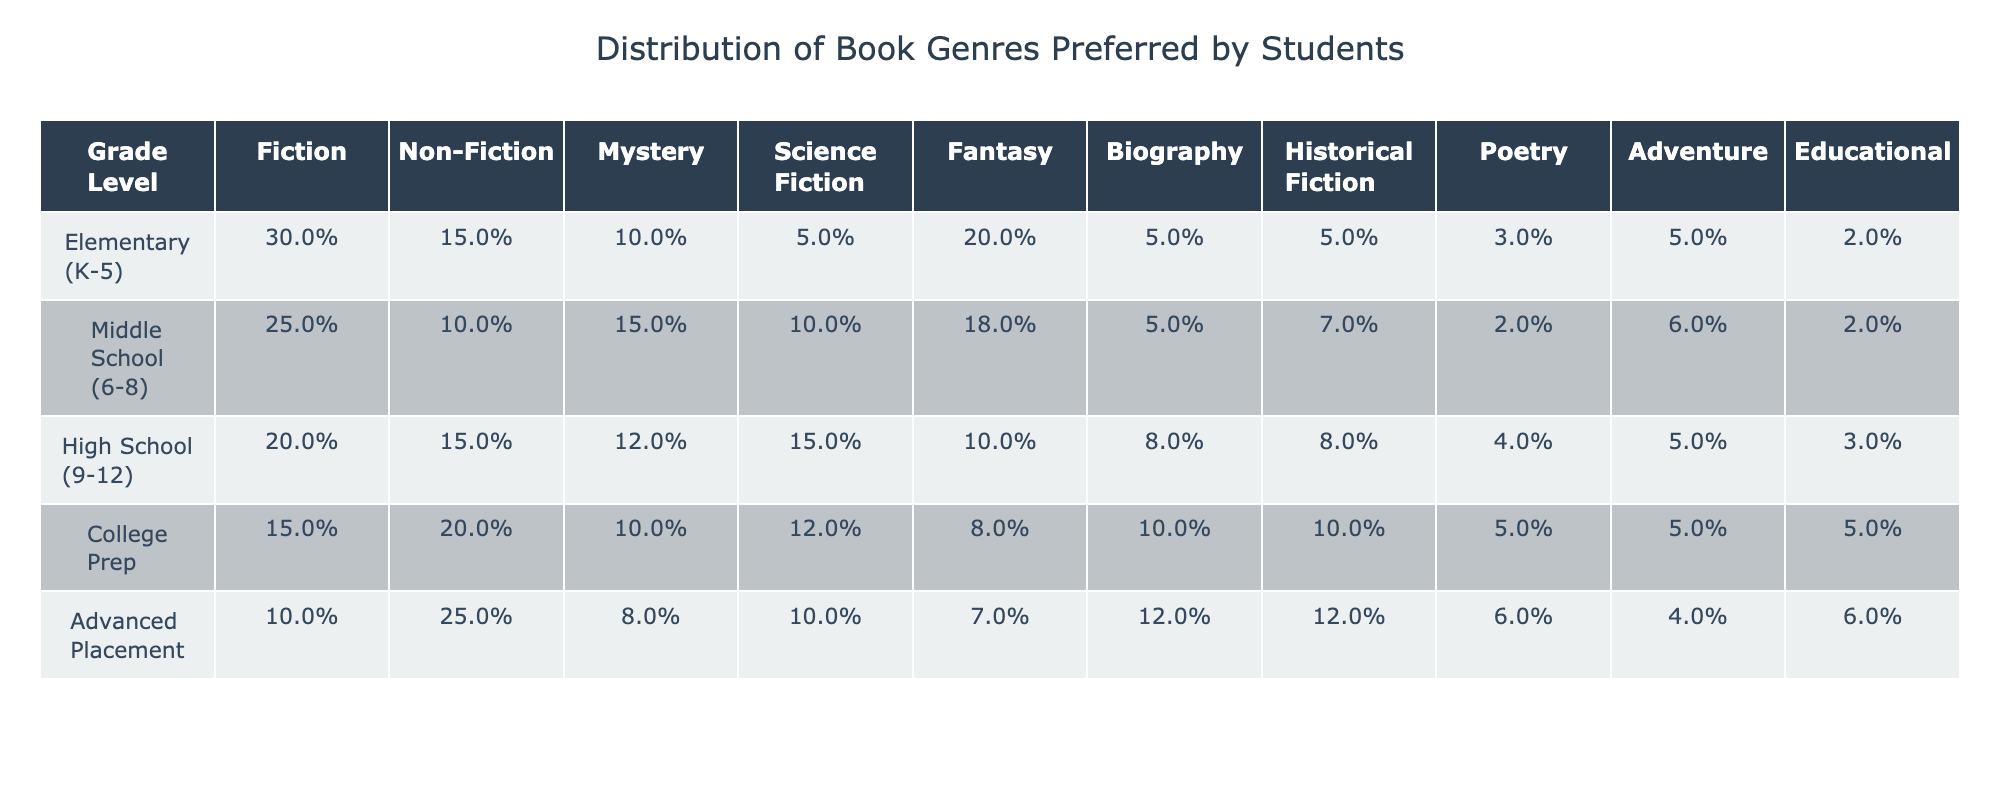What percentage of Elementary students prefer Fantasy books? Looking at the 'Elementary (K-5)' row under the 'Fantasy' column, it shows 20%.
Answer: 20% Which grade level has the highest preference for Non-Fiction? The 'Non-Fiction' column indicates that the highest preference is 25%, found in the 'Advanced Placement' row.
Answer: Advanced Placement What is the total percentage of genres preferred by Middle School students that are Adventure or Educational? Adding the percentages for Adventure (6%) and Educational (2%) in the Middle School row gives 6% + 2% = 8%.
Answer: 8% Do High School students prefer Fiction or Non-Fiction more? The 'Fiction' column shows 20% and the 'Non-Fiction' column shows 15%; thus, Fiction is preferred more by 5%.
Answer: Fiction Which genre has the lowest percentage preference among College Prep students? Looking at the 'College Prep' row, the lowest percentage is for Adventure and Educational, both at 5%.
Answer: Adventure and Educational What percentage difference in preference for Mystery exists between Middle School and High School students? Middle School has 15% and High School has 12%. The difference is 15% - 12% = 3%.
Answer: 3% Which grade level has the highest total preference for Science Fiction and Fantasy combined? For 'Science Fiction' (10%) and 'Fantasy' (18%) in Middle School, the total is 10% + 18% = 28%, which is the highest across all grade levels.
Answer: Middle School Is there a clear trend in the preference for Fiction from Elementary to Advanced Placement students? Yes, the preference for Fiction decreases from 30% in Elementary, 25% in Middle School, 20% in High School, and 15% in College Prep, resulting in a consistent decline.
Answer: Yes What is the average preference percentage for Historical Fiction across all grade levels? Adding the Historical Fiction percentages (5% + 7% + 8% + 10% + 12%) gives a total of 42%. Dividing by the number of grade levels (5) yields an average of 42% / 5 = 8.4%.
Answer: 8.4% Which genre is most preferred by High School students after Fiction? After Fiction (20%), the next highest is Non-Fiction at 15%.
Answer: Non-Fiction 